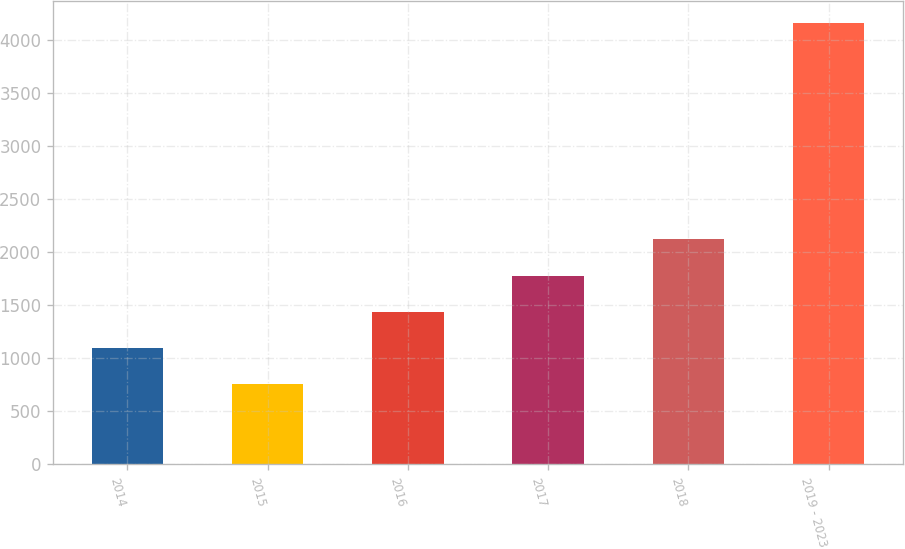Convert chart. <chart><loc_0><loc_0><loc_500><loc_500><bar_chart><fcel>2014<fcel>2015<fcel>2016<fcel>2017<fcel>2018<fcel>2019 - 2023<nl><fcel>1099.6<fcel>759<fcel>1440.2<fcel>1780.8<fcel>2121.4<fcel>4165<nl></chart> 